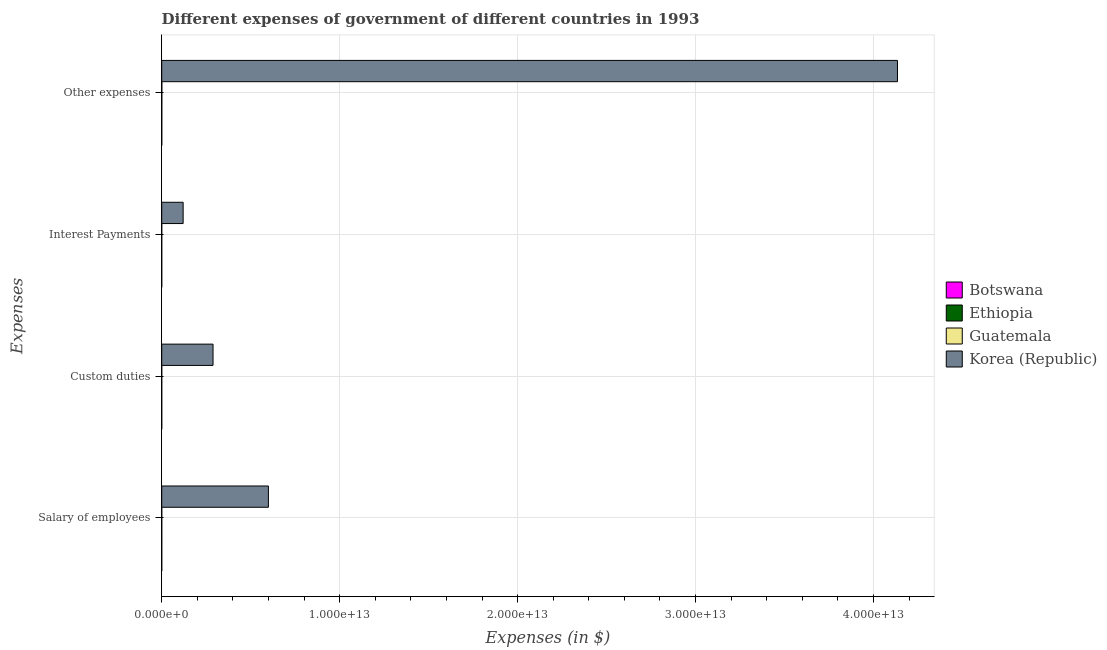How many different coloured bars are there?
Offer a very short reply. 4. Are the number of bars per tick equal to the number of legend labels?
Give a very brief answer. Yes. Are the number of bars on each tick of the Y-axis equal?
Offer a terse response. Yes. What is the label of the 2nd group of bars from the top?
Your answer should be compact. Interest Payments. What is the amount spent on custom duties in Ethiopia?
Your answer should be compact. 7.04e+08. Across all countries, what is the maximum amount spent on other expenses?
Your answer should be very brief. 4.13e+13. Across all countries, what is the minimum amount spent on custom duties?
Ensure brevity in your answer.  7.04e+08. In which country was the amount spent on interest payments minimum?
Offer a terse response. Botswana. What is the total amount spent on interest payments in the graph?
Ensure brevity in your answer.  1.21e+12. What is the difference between the amount spent on custom duties in Ethiopia and that in Korea (Republic)?
Keep it short and to the point. -2.88e+12. What is the difference between the amount spent on interest payments in Ethiopia and the amount spent on custom duties in Botswana?
Ensure brevity in your answer.  -2.92e+08. What is the average amount spent on other expenses per country?
Your answer should be compact. 1.03e+13. What is the difference between the amount spent on other expenses and amount spent on custom duties in Botswana?
Keep it short and to the point. 2.47e+09. In how many countries, is the amount spent on custom duties greater than 24000000000000 $?
Offer a terse response. 0. What is the ratio of the amount spent on interest payments in Korea (Republic) to that in Botswana?
Provide a short and direct response. 1.53e+04. Is the amount spent on other expenses in Ethiopia less than that in Botswana?
Your answer should be very brief. No. Is the difference between the amount spent on custom duties in Korea (Republic) and Ethiopia greater than the difference between the amount spent on interest payments in Korea (Republic) and Ethiopia?
Provide a short and direct response. Yes. What is the difference between the highest and the second highest amount spent on custom duties?
Give a very brief answer. 2.88e+12. What is the difference between the highest and the lowest amount spent on salary of employees?
Make the answer very short. 5.99e+12. Is it the case that in every country, the sum of the amount spent on other expenses and amount spent on interest payments is greater than the sum of amount spent on salary of employees and amount spent on custom duties?
Offer a very short reply. No. What does the 3rd bar from the top in Interest Payments represents?
Provide a succinct answer. Ethiopia. How many bars are there?
Offer a very short reply. 16. What is the difference between two consecutive major ticks on the X-axis?
Offer a terse response. 1.00e+13. Are the values on the major ticks of X-axis written in scientific E-notation?
Provide a succinct answer. Yes. Does the graph contain grids?
Make the answer very short. Yes. How many legend labels are there?
Your response must be concise. 4. What is the title of the graph?
Make the answer very short. Different expenses of government of different countries in 1993. Does "Bhutan" appear as one of the legend labels in the graph?
Keep it short and to the point. No. What is the label or title of the X-axis?
Your response must be concise. Expenses (in $). What is the label or title of the Y-axis?
Your response must be concise. Expenses. What is the Expenses (in $) of Botswana in Salary of employees?
Provide a succinct answer. 1.13e+09. What is the Expenses (in $) of Ethiopia in Salary of employees?
Offer a terse response. 1.87e+09. What is the Expenses (in $) of Guatemala in Salary of employees?
Make the answer very short. 2.27e+09. What is the Expenses (in $) of Korea (Republic) in Salary of employees?
Ensure brevity in your answer.  6.00e+12. What is the Expenses (in $) of Botswana in Custom duties?
Ensure brevity in your answer.  8.23e+08. What is the Expenses (in $) of Ethiopia in Custom duties?
Provide a succinct answer. 7.04e+08. What is the Expenses (in $) in Guatemala in Custom duties?
Give a very brief answer. 1.13e+09. What is the Expenses (in $) of Korea (Republic) in Custom duties?
Your answer should be very brief. 2.88e+12. What is the Expenses (in $) of Botswana in Interest Payments?
Offer a terse response. 7.87e+07. What is the Expenses (in $) in Ethiopia in Interest Payments?
Keep it short and to the point. 5.30e+08. What is the Expenses (in $) in Guatemala in Interest Payments?
Keep it short and to the point. 5.79e+08. What is the Expenses (in $) of Korea (Republic) in Interest Payments?
Keep it short and to the point. 1.20e+12. What is the Expenses (in $) in Botswana in Other expenses?
Give a very brief answer. 3.29e+09. What is the Expenses (in $) of Ethiopia in Other expenses?
Your answer should be compact. 3.95e+09. What is the Expenses (in $) of Guatemala in Other expenses?
Ensure brevity in your answer.  5.54e+09. What is the Expenses (in $) of Korea (Republic) in Other expenses?
Your answer should be compact. 4.13e+13. Across all Expenses, what is the maximum Expenses (in $) of Botswana?
Your answer should be compact. 3.29e+09. Across all Expenses, what is the maximum Expenses (in $) of Ethiopia?
Keep it short and to the point. 3.95e+09. Across all Expenses, what is the maximum Expenses (in $) of Guatemala?
Make the answer very short. 5.54e+09. Across all Expenses, what is the maximum Expenses (in $) in Korea (Republic)?
Give a very brief answer. 4.13e+13. Across all Expenses, what is the minimum Expenses (in $) in Botswana?
Your response must be concise. 7.87e+07. Across all Expenses, what is the minimum Expenses (in $) in Ethiopia?
Make the answer very short. 5.30e+08. Across all Expenses, what is the minimum Expenses (in $) of Guatemala?
Your answer should be compact. 5.79e+08. Across all Expenses, what is the minimum Expenses (in $) in Korea (Republic)?
Offer a terse response. 1.20e+12. What is the total Expenses (in $) in Botswana in the graph?
Give a very brief answer. 5.32e+09. What is the total Expenses (in $) of Ethiopia in the graph?
Keep it short and to the point. 7.05e+09. What is the total Expenses (in $) in Guatemala in the graph?
Ensure brevity in your answer.  9.52e+09. What is the total Expenses (in $) of Korea (Republic) in the graph?
Provide a short and direct response. 5.14e+13. What is the difference between the Expenses (in $) of Botswana in Salary of employees and that in Custom duties?
Your answer should be very brief. 3.11e+08. What is the difference between the Expenses (in $) in Ethiopia in Salary of employees and that in Custom duties?
Give a very brief answer. 1.17e+09. What is the difference between the Expenses (in $) of Guatemala in Salary of employees and that in Custom duties?
Give a very brief answer. 1.14e+09. What is the difference between the Expenses (in $) in Korea (Republic) in Salary of employees and that in Custom duties?
Your answer should be very brief. 3.11e+12. What is the difference between the Expenses (in $) in Botswana in Salary of employees and that in Interest Payments?
Give a very brief answer. 1.05e+09. What is the difference between the Expenses (in $) of Ethiopia in Salary of employees and that in Interest Payments?
Keep it short and to the point. 1.34e+09. What is the difference between the Expenses (in $) in Guatemala in Salary of employees and that in Interest Payments?
Give a very brief answer. 1.69e+09. What is the difference between the Expenses (in $) of Korea (Republic) in Salary of employees and that in Interest Payments?
Your answer should be compact. 4.79e+12. What is the difference between the Expenses (in $) of Botswana in Salary of employees and that in Other expenses?
Offer a very short reply. -2.16e+09. What is the difference between the Expenses (in $) in Ethiopia in Salary of employees and that in Other expenses?
Keep it short and to the point. -2.08e+09. What is the difference between the Expenses (in $) in Guatemala in Salary of employees and that in Other expenses?
Give a very brief answer. -3.27e+09. What is the difference between the Expenses (in $) of Korea (Republic) in Salary of employees and that in Other expenses?
Your response must be concise. -3.54e+13. What is the difference between the Expenses (in $) in Botswana in Custom duties and that in Interest Payments?
Your response must be concise. 7.44e+08. What is the difference between the Expenses (in $) in Ethiopia in Custom duties and that in Interest Payments?
Your response must be concise. 1.73e+08. What is the difference between the Expenses (in $) in Guatemala in Custom duties and that in Interest Payments?
Offer a very short reply. 5.55e+08. What is the difference between the Expenses (in $) in Korea (Republic) in Custom duties and that in Interest Payments?
Offer a very short reply. 1.68e+12. What is the difference between the Expenses (in $) in Botswana in Custom duties and that in Other expenses?
Provide a succinct answer. -2.47e+09. What is the difference between the Expenses (in $) in Ethiopia in Custom duties and that in Other expenses?
Provide a succinct answer. -3.24e+09. What is the difference between the Expenses (in $) in Guatemala in Custom duties and that in Other expenses?
Keep it short and to the point. -4.41e+09. What is the difference between the Expenses (in $) of Korea (Republic) in Custom duties and that in Other expenses?
Offer a very short reply. -3.85e+13. What is the difference between the Expenses (in $) in Botswana in Interest Payments and that in Other expenses?
Your answer should be very brief. -3.21e+09. What is the difference between the Expenses (in $) in Ethiopia in Interest Payments and that in Other expenses?
Your response must be concise. -3.42e+09. What is the difference between the Expenses (in $) in Guatemala in Interest Payments and that in Other expenses?
Provide a short and direct response. -4.96e+09. What is the difference between the Expenses (in $) of Korea (Republic) in Interest Payments and that in Other expenses?
Your answer should be very brief. -4.01e+13. What is the difference between the Expenses (in $) of Botswana in Salary of employees and the Expenses (in $) of Ethiopia in Custom duties?
Provide a short and direct response. 4.30e+08. What is the difference between the Expenses (in $) in Botswana in Salary of employees and the Expenses (in $) in Guatemala in Custom duties?
Your answer should be very brief. -3.40e+05. What is the difference between the Expenses (in $) in Botswana in Salary of employees and the Expenses (in $) in Korea (Republic) in Custom duties?
Provide a succinct answer. -2.88e+12. What is the difference between the Expenses (in $) of Ethiopia in Salary of employees and the Expenses (in $) of Guatemala in Custom duties?
Make the answer very short. 7.36e+08. What is the difference between the Expenses (in $) in Ethiopia in Salary of employees and the Expenses (in $) in Korea (Republic) in Custom duties?
Offer a terse response. -2.88e+12. What is the difference between the Expenses (in $) of Guatemala in Salary of employees and the Expenses (in $) of Korea (Republic) in Custom duties?
Offer a terse response. -2.88e+12. What is the difference between the Expenses (in $) in Botswana in Salary of employees and the Expenses (in $) in Ethiopia in Interest Payments?
Your answer should be very brief. 6.03e+08. What is the difference between the Expenses (in $) in Botswana in Salary of employees and the Expenses (in $) in Guatemala in Interest Payments?
Your response must be concise. 5.55e+08. What is the difference between the Expenses (in $) in Botswana in Salary of employees and the Expenses (in $) in Korea (Republic) in Interest Payments?
Your answer should be very brief. -1.20e+12. What is the difference between the Expenses (in $) of Ethiopia in Salary of employees and the Expenses (in $) of Guatemala in Interest Payments?
Offer a very short reply. 1.29e+09. What is the difference between the Expenses (in $) of Ethiopia in Salary of employees and the Expenses (in $) of Korea (Republic) in Interest Payments?
Provide a short and direct response. -1.20e+12. What is the difference between the Expenses (in $) of Guatemala in Salary of employees and the Expenses (in $) of Korea (Republic) in Interest Payments?
Offer a very short reply. -1.20e+12. What is the difference between the Expenses (in $) in Botswana in Salary of employees and the Expenses (in $) in Ethiopia in Other expenses?
Provide a short and direct response. -2.81e+09. What is the difference between the Expenses (in $) in Botswana in Salary of employees and the Expenses (in $) in Guatemala in Other expenses?
Provide a short and direct response. -4.41e+09. What is the difference between the Expenses (in $) of Botswana in Salary of employees and the Expenses (in $) of Korea (Republic) in Other expenses?
Make the answer very short. -4.13e+13. What is the difference between the Expenses (in $) in Ethiopia in Salary of employees and the Expenses (in $) in Guatemala in Other expenses?
Make the answer very short. -3.67e+09. What is the difference between the Expenses (in $) in Ethiopia in Salary of employees and the Expenses (in $) in Korea (Republic) in Other expenses?
Give a very brief answer. -4.13e+13. What is the difference between the Expenses (in $) in Guatemala in Salary of employees and the Expenses (in $) in Korea (Republic) in Other expenses?
Offer a very short reply. -4.13e+13. What is the difference between the Expenses (in $) of Botswana in Custom duties and the Expenses (in $) of Ethiopia in Interest Payments?
Keep it short and to the point. 2.92e+08. What is the difference between the Expenses (in $) in Botswana in Custom duties and the Expenses (in $) in Guatemala in Interest Payments?
Keep it short and to the point. 2.44e+08. What is the difference between the Expenses (in $) in Botswana in Custom duties and the Expenses (in $) in Korea (Republic) in Interest Payments?
Offer a terse response. -1.20e+12. What is the difference between the Expenses (in $) in Ethiopia in Custom duties and the Expenses (in $) in Guatemala in Interest Payments?
Offer a very short reply. 1.25e+08. What is the difference between the Expenses (in $) of Ethiopia in Custom duties and the Expenses (in $) of Korea (Republic) in Interest Payments?
Your response must be concise. -1.20e+12. What is the difference between the Expenses (in $) of Guatemala in Custom duties and the Expenses (in $) of Korea (Republic) in Interest Payments?
Offer a very short reply. -1.20e+12. What is the difference between the Expenses (in $) in Botswana in Custom duties and the Expenses (in $) in Ethiopia in Other expenses?
Give a very brief answer. -3.13e+09. What is the difference between the Expenses (in $) in Botswana in Custom duties and the Expenses (in $) in Guatemala in Other expenses?
Offer a terse response. -4.72e+09. What is the difference between the Expenses (in $) in Botswana in Custom duties and the Expenses (in $) in Korea (Republic) in Other expenses?
Give a very brief answer. -4.13e+13. What is the difference between the Expenses (in $) in Ethiopia in Custom duties and the Expenses (in $) in Guatemala in Other expenses?
Provide a short and direct response. -4.84e+09. What is the difference between the Expenses (in $) of Ethiopia in Custom duties and the Expenses (in $) of Korea (Republic) in Other expenses?
Keep it short and to the point. -4.13e+13. What is the difference between the Expenses (in $) of Guatemala in Custom duties and the Expenses (in $) of Korea (Republic) in Other expenses?
Offer a very short reply. -4.13e+13. What is the difference between the Expenses (in $) in Botswana in Interest Payments and the Expenses (in $) in Ethiopia in Other expenses?
Your response must be concise. -3.87e+09. What is the difference between the Expenses (in $) in Botswana in Interest Payments and the Expenses (in $) in Guatemala in Other expenses?
Your response must be concise. -5.46e+09. What is the difference between the Expenses (in $) of Botswana in Interest Payments and the Expenses (in $) of Korea (Republic) in Other expenses?
Offer a terse response. -4.13e+13. What is the difference between the Expenses (in $) in Ethiopia in Interest Payments and the Expenses (in $) in Guatemala in Other expenses?
Your response must be concise. -5.01e+09. What is the difference between the Expenses (in $) in Ethiopia in Interest Payments and the Expenses (in $) in Korea (Republic) in Other expenses?
Your answer should be very brief. -4.13e+13. What is the difference between the Expenses (in $) of Guatemala in Interest Payments and the Expenses (in $) of Korea (Republic) in Other expenses?
Offer a very short reply. -4.13e+13. What is the average Expenses (in $) in Botswana per Expenses?
Your answer should be compact. 1.33e+09. What is the average Expenses (in $) of Ethiopia per Expenses?
Your answer should be very brief. 1.76e+09. What is the average Expenses (in $) in Guatemala per Expenses?
Provide a succinct answer. 2.38e+09. What is the average Expenses (in $) of Korea (Republic) per Expenses?
Offer a terse response. 1.29e+13. What is the difference between the Expenses (in $) in Botswana and Expenses (in $) in Ethiopia in Salary of employees?
Offer a very short reply. -7.36e+08. What is the difference between the Expenses (in $) of Botswana and Expenses (in $) of Guatemala in Salary of employees?
Your answer should be compact. -1.14e+09. What is the difference between the Expenses (in $) in Botswana and Expenses (in $) in Korea (Republic) in Salary of employees?
Your response must be concise. -5.99e+12. What is the difference between the Expenses (in $) of Ethiopia and Expenses (in $) of Guatemala in Salary of employees?
Ensure brevity in your answer.  -4.00e+08. What is the difference between the Expenses (in $) of Ethiopia and Expenses (in $) of Korea (Republic) in Salary of employees?
Your answer should be compact. -5.99e+12. What is the difference between the Expenses (in $) in Guatemala and Expenses (in $) in Korea (Republic) in Salary of employees?
Offer a terse response. -5.99e+12. What is the difference between the Expenses (in $) of Botswana and Expenses (in $) of Ethiopia in Custom duties?
Provide a short and direct response. 1.19e+08. What is the difference between the Expenses (in $) of Botswana and Expenses (in $) of Guatemala in Custom duties?
Give a very brief answer. -3.11e+08. What is the difference between the Expenses (in $) in Botswana and Expenses (in $) in Korea (Republic) in Custom duties?
Offer a very short reply. -2.88e+12. What is the difference between the Expenses (in $) in Ethiopia and Expenses (in $) in Guatemala in Custom duties?
Provide a short and direct response. -4.30e+08. What is the difference between the Expenses (in $) of Ethiopia and Expenses (in $) of Korea (Republic) in Custom duties?
Give a very brief answer. -2.88e+12. What is the difference between the Expenses (in $) of Guatemala and Expenses (in $) of Korea (Republic) in Custom duties?
Offer a very short reply. -2.88e+12. What is the difference between the Expenses (in $) of Botswana and Expenses (in $) of Ethiopia in Interest Payments?
Offer a terse response. -4.52e+08. What is the difference between the Expenses (in $) in Botswana and Expenses (in $) in Guatemala in Interest Payments?
Provide a short and direct response. -5.00e+08. What is the difference between the Expenses (in $) in Botswana and Expenses (in $) in Korea (Republic) in Interest Payments?
Make the answer very short. -1.20e+12. What is the difference between the Expenses (in $) of Ethiopia and Expenses (in $) of Guatemala in Interest Payments?
Give a very brief answer. -4.83e+07. What is the difference between the Expenses (in $) in Ethiopia and Expenses (in $) in Korea (Republic) in Interest Payments?
Make the answer very short. -1.20e+12. What is the difference between the Expenses (in $) in Guatemala and Expenses (in $) in Korea (Republic) in Interest Payments?
Make the answer very short. -1.20e+12. What is the difference between the Expenses (in $) in Botswana and Expenses (in $) in Ethiopia in Other expenses?
Your answer should be very brief. -6.59e+08. What is the difference between the Expenses (in $) in Botswana and Expenses (in $) in Guatemala in Other expenses?
Ensure brevity in your answer.  -2.25e+09. What is the difference between the Expenses (in $) in Botswana and Expenses (in $) in Korea (Republic) in Other expenses?
Give a very brief answer. -4.13e+13. What is the difference between the Expenses (in $) of Ethiopia and Expenses (in $) of Guatemala in Other expenses?
Offer a terse response. -1.59e+09. What is the difference between the Expenses (in $) of Ethiopia and Expenses (in $) of Korea (Republic) in Other expenses?
Provide a succinct answer. -4.13e+13. What is the difference between the Expenses (in $) in Guatemala and Expenses (in $) in Korea (Republic) in Other expenses?
Offer a very short reply. -4.13e+13. What is the ratio of the Expenses (in $) of Botswana in Salary of employees to that in Custom duties?
Your answer should be compact. 1.38. What is the ratio of the Expenses (in $) in Ethiopia in Salary of employees to that in Custom duties?
Give a very brief answer. 2.66. What is the ratio of the Expenses (in $) of Guatemala in Salary of employees to that in Custom duties?
Your response must be concise. 2. What is the ratio of the Expenses (in $) in Korea (Republic) in Salary of employees to that in Custom duties?
Give a very brief answer. 2.08. What is the ratio of the Expenses (in $) of Botswana in Salary of employees to that in Interest Payments?
Your answer should be very brief. 14.4. What is the ratio of the Expenses (in $) of Ethiopia in Salary of employees to that in Interest Payments?
Make the answer very short. 3.52. What is the ratio of the Expenses (in $) of Guatemala in Salary of employees to that in Interest Payments?
Keep it short and to the point. 3.92. What is the ratio of the Expenses (in $) in Korea (Republic) in Salary of employees to that in Interest Payments?
Your response must be concise. 4.98. What is the ratio of the Expenses (in $) of Botswana in Salary of employees to that in Other expenses?
Your response must be concise. 0.34. What is the ratio of the Expenses (in $) in Ethiopia in Salary of employees to that in Other expenses?
Your answer should be compact. 0.47. What is the ratio of the Expenses (in $) in Guatemala in Salary of employees to that in Other expenses?
Give a very brief answer. 0.41. What is the ratio of the Expenses (in $) of Korea (Republic) in Salary of employees to that in Other expenses?
Keep it short and to the point. 0.14. What is the ratio of the Expenses (in $) in Botswana in Custom duties to that in Interest Payments?
Give a very brief answer. 10.46. What is the ratio of the Expenses (in $) of Ethiopia in Custom duties to that in Interest Payments?
Your answer should be very brief. 1.33. What is the ratio of the Expenses (in $) in Guatemala in Custom duties to that in Interest Payments?
Offer a very short reply. 1.96. What is the ratio of the Expenses (in $) of Korea (Republic) in Custom duties to that in Interest Payments?
Offer a very short reply. 2.4. What is the ratio of the Expenses (in $) in Botswana in Custom duties to that in Other expenses?
Ensure brevity in your answer.  0.25. What is the ratio of the Expenses (in $) of Ethiopia in Custom duties to that in Other expenses?
Ensure brevity in your answer.  0.18. What is the ratio of the Expenses (in $) of Guatemala in Custom duties to that in Other expenses?
Provide a succinct answer. 0.2. What is the ratio of the Expenses (in $) in Korea (Republic) in Custom duties to that in Other expenses?
Offer a very short reply. 0.07. What is the ratio of the Expenses (in $) in Botswana in Interest Payments to that in Other expenses?
Make the answer very short. 0.02. What is the ratio of the Expenses (in $) in Ethiopia in Interest Payments to that in Other expenses?
Offer a very short reply. 0.13. What is the ratio of the Expenses (in $) of Guatemala in Interest Payments to that in Other expenses?
Provide a succinct answer. 0.1. What is the ratio of the Expenses (in $) in Korea (Republic) in Interest Payments to that in Other expenses?
Your answer should be compact. 0.03. What is the difference between the highest and the second highest Expenses (in $) of Botswana?
Your answer should be very brief. 2.16e+09. What is the difference between the highest and the second highest Expenses (in $) in Ethiopia?
Ensure brevity in your answer.  2.08e+09. What is the difference between the highest and the second highest Expenses (in $) of Guatemala?
Make the answer very short. 3.27e+09. What is the difference between the highest and the second highest Expenses (in $) of Korea (Republic)?
Provide a short and direct response. 3.54e+13. What is the difference between the highest and the lowest Expenses (in $) of Botswana?
Offer a very short reply. 3.21e+09. What is the difference between the highest and the lowest Expenses (in $) of Ethiopia?
Give a very brief answer. 3.42e+09. What is the difference between the highest and the lowest Expenses (in $) of Guatemala?
Provide a short and direct response. 4.96e+09. What is the difference between the highest and the lowest Expenses (in $) of Korea (Republic)?
Offer a terse response. 4.01e+13. 